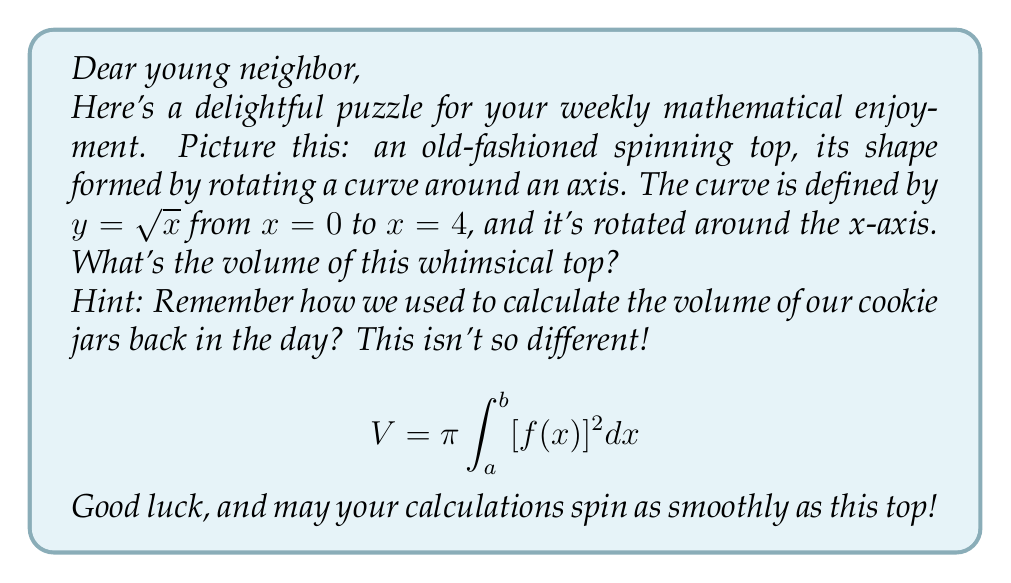Help me with this question. To solve this puzzle, we'll use the method of calculating the volume of a solid of revolution. Here's how we'll approach it:

1) We're given that the curve $y = \sqrt{x}$ is rotated around the x-axis from $x = 0$ to $x = 4$. This forms our solid.

2) The formula for the volume of a solid of revolution around the x-axis is:

   $$V = \pi \int_a^b [f(x)]^2 dx$$

   where $f(x)$ is our function, and $a$ and $b$ are our limits of integration.

3) In our case, $f(x) = \sqrt{x}$, $a = 0$, and $b = 4$. Let's substitute these into our formula:

   $$V = \pi \int_0^4 (\sqrt{x})^2 dx$$

4) Simplify the integrand:

   $$V = \pi \int_0^4 x dx$$

5) Now we can integrate:

   $$V = \pi \left[\frac{1}{2}x^2\right]_0^4$$

6) Evaluate the integral:

   $$V = \pi \left(\frac{1}{2}(4^2) - \frac{1}{2}(0^2)\right)$$

   $$V = \pi \left(8 - 0\right)$$

   $$V = 8\pi$$

Therefore, the volume of our spinning top is $8\pi$ cubic units.
Answer: $8\pi$ cubic units 